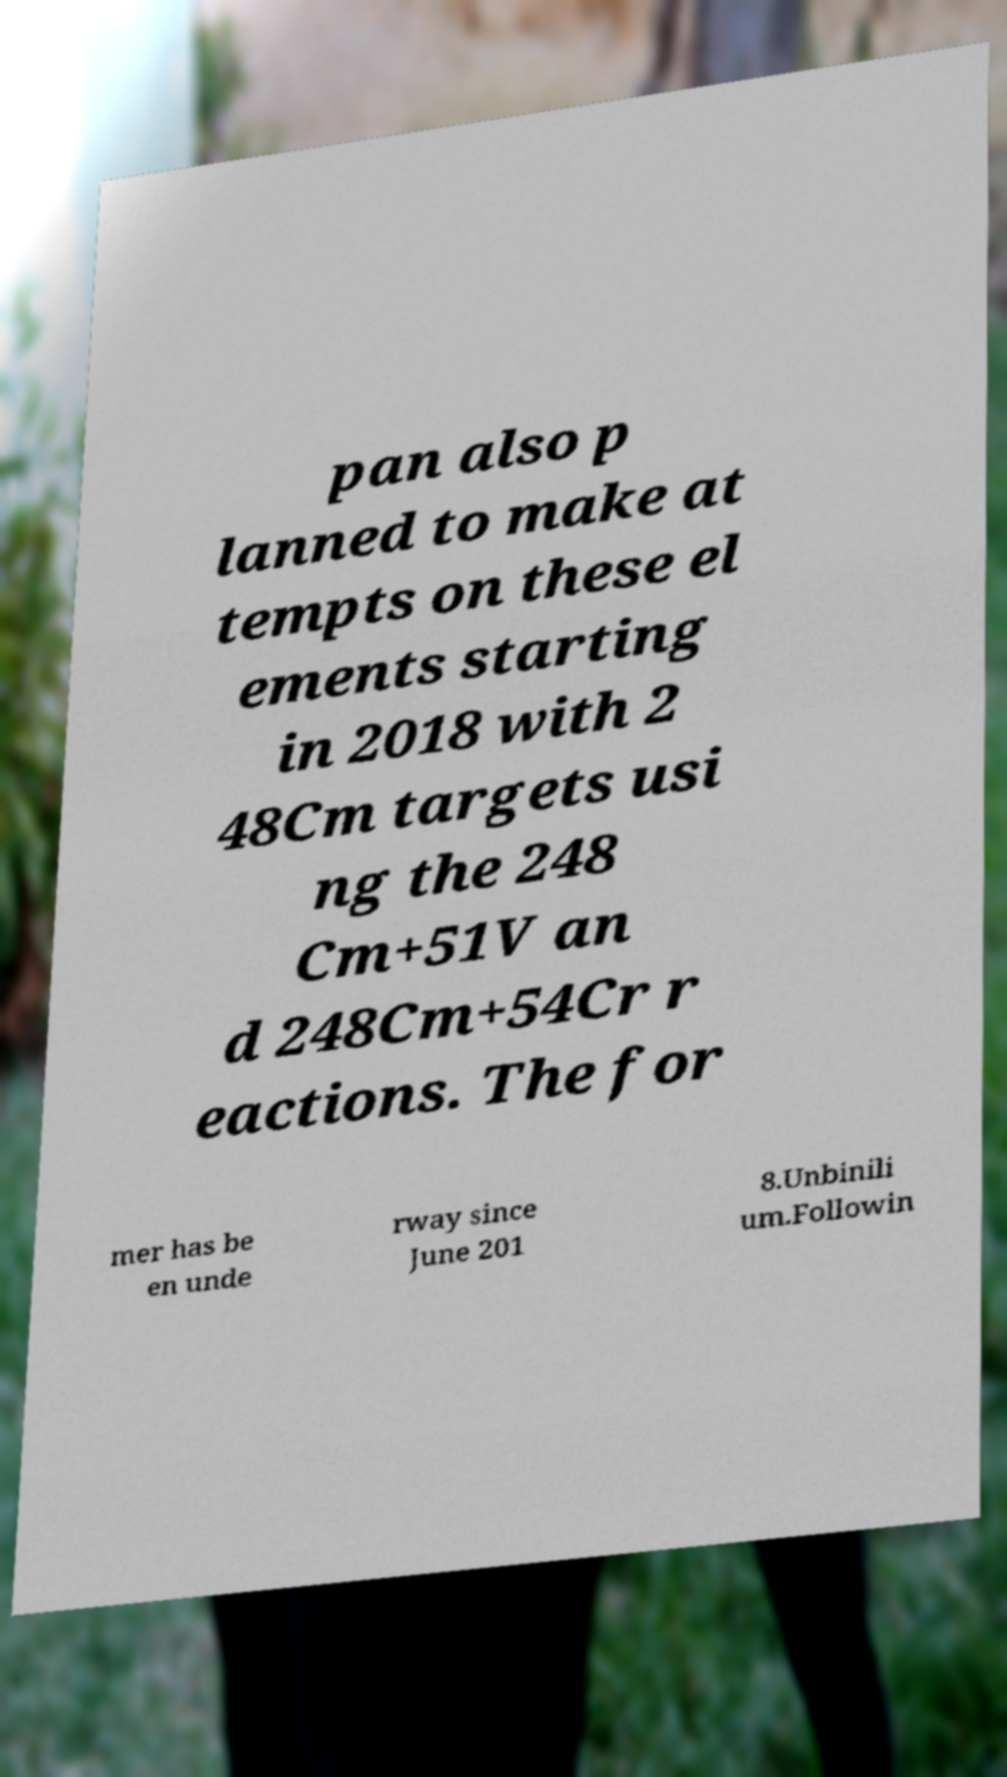What messages or text are displayed in this image? I need them in a readable, typed format. pan also p lanned to make at tempts on these el ements starting in 2018 with 2 48Cm targets usi ng the 248 Cm+51V an d 248Cm+54Cr r eactions. The for mer has be en unde rway since June 201 8.Unbinili um.Followin 